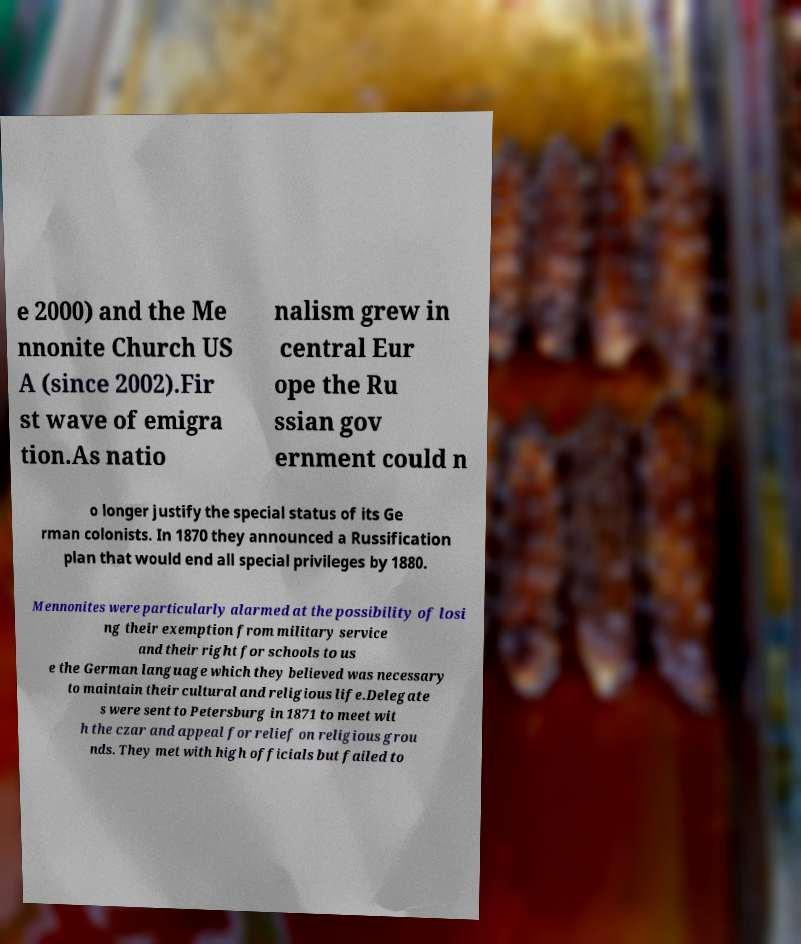Can you accurately transcribe the text from the provided image for me? e 2000) and the Me nnonite Church US A (since 2002).Fir st wave of emigra tion.As natio nalism grew in central Eur ope the Ru ssian gov ernment could n o longer justify the special status of its Ge rman colonists. In 1870 they announced a Russification plan that would end all special privileges by 1880. Mennonites were particularly alarmed at the possibility of losi ng their exemption from military service and their right for schools to us e the German language which they believed was necessary to maintain their cultural and religious life.Delegate s were sent to Petersburg in 1871 to meet wit h the czar and appeal for relief on religious grou nds. They met with high officials but failed to 